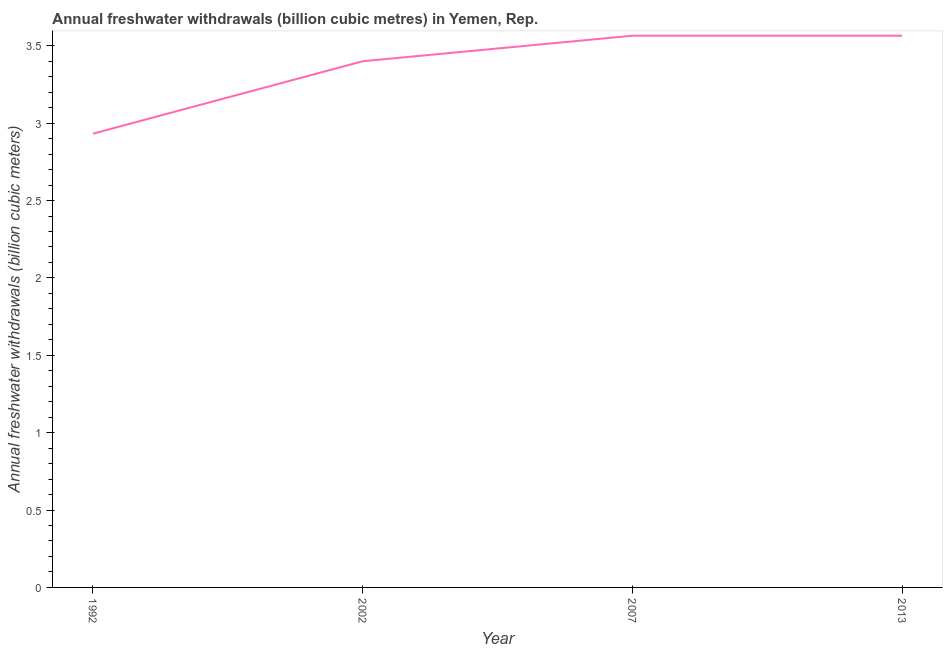What is the annual freshwater withdrawals in 2007?
Ensure brevity in your answer.  3.56. Across all years, what is the maximum annual freshwater withdrawals?
Provide a short and direct response. 3.56. Across all years, what is the minimum annual freshwater withdrawals?
Give a very brief answer. 2.93. In which year was the annual freshwater withdrawals minimum?
Provide a succinct answer. 1992. What is the sum of the annual freshwater withdrawals?
Keep it short and to the point. 13.46. What is the difference between the annual freshwater withdrawals in 1992 and 2013?
Your response must be concise. -0.63. What is the average annual freshwater withdrawals per year?
Offer a very short reply. 3.37. What is the median annual freshwater withdrawals?
Offer a very short reply. 3.48. In how many years, is the annual freshwater withdrawals greater than 1 billion cubic meters?
Your answer should be compact. 4. What is the ratio of the annual freshwater withdrawals in 2002 to that in 2007?
Give a very brief answer. 0.95. Is the annual freshwater withdrawals in 1992 less than that in 2007?
Ensure brevity in your answer.  Yes. Is the difference between the annual freshwater withdrawals in 1992 and 2002 greater than the difference between any two years?
Ensure brevity in your answer.  No. Is the sum of the annual freshwater withdrawals in 1992 and 2013 greater than the maximum annual freshwater withdrawals across all years?
Your answer should be compact. Yes. What is the difference between the highest and the lowest annual freshwater withdrawals?
Your answer should be very brief. 0.63. Does the annual freshwater withdrawals monotonically increase over the years?
Keep it short and to the point. No. What is the difference between two consecutive major ticks on the Y-axis?
Give a very brief answer. 0.5. Are the values on the major ticks of Y-axis written in scientific E-notation?
Your answer should be very brief. No. Does the graph contain any zero values?
Provide a short and direct response. No. Does the graph contain grids?
Provide a succinct answer. No. What is the title of the graph?
Keep it short and to the point. Annual freshwater withdrawals (billion cubic metres) in Yemen, Rep. What is the label or title of the Y-axis?
Make the answer very short. Annual freshwater withdrawals (billion cubic meters). What is the Annual freshwater withdrawals (billion cubic meters) in 1992?
Keep it short and to the point. 2.93. What is the Annual freshwater withdrawals (billion cubic meters) of 2007?
Your response must be concise. 3.56. What is the Annual freshwater withdrawals (billion cubic meters) of 2013?
Offer a very short reply. 3.56. What is the difference between the Annual freshwater withdrawals (billion cubic meters) in 1992 and 2002?
Give a very brief answer. -0.47. What is the difference between the Annual freshwater withdrawals (billion cubic meters) in 1992 and 2007?
Provide a succinct answer. -0.63. What is the difference between the Annual freshwater withdrawals (billion cubic meters) in 1992 and 2013?
Make the answer very short. -0.63. What is the difference between the Annual freshwater withdrawals (billion cubic meters) in 2002 and 2007?
Your answer should be compact. -0.17. What is the difference between the Annual freshwater withdrawals (billion cubic meters) in 2002 and 2013?
Your answer should be compact. -0.17. What is the difference between the Annual freshwater withdrawals (billion cubic meters) in 2007 and 2013?
Your answer should be very brief. 0. What is the ratio of the Annual freshwater withdrawals (billion cubic meters) in 1992 to that in 2002?
Make the answer very short. 0.86. What is the ratio of the Annual freshwater withdrawals (billion cubic meters) in 1992 to that in 2007?
Your answer should be compact. 0.82. What is the ratio of the Annual freshwater withdrawals (billion cubic meters) in 1992 to that in 2013?
Offer a very short reply. 0.82. What is the ratio of the Annual freshwater withdrawals (billion cubic meters) in 2002 to that in 2007?
Give a very brief answer. 0.95. What is the ratio of the Annual freshwater withdrawals (billion cubic meters) in 2002 to that in 2013?
Your response must be concise. 0.95. 